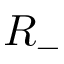Convert formula to latex. <formula><loc_0><loc_0><loc_500><loc_500>R _ { - }</formula> 